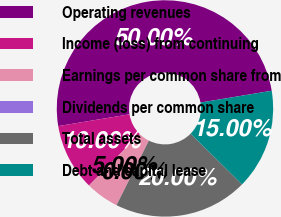Convert chart. <chart><loc_0><loc_0><loc_500><loc_500><pie_chart><fcel>Operating revenues<fcel>Income (loss) from continuing<fcel>Earnings per common share from<fcel>Dividends per common share<fcel>Total assets<fcel>Debt and capital lease<nl><fcel>50.0%<fcel>10.0%<fcel>5.0%<fcel>0.0%<fcel>20.0%<fcel>15.0%<nl></chart> 